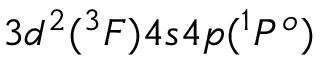Convert formula to latex. <formula><loc_0><loc_0><loc_500><loc_500>3 d ^ { 2 } ( ^ { 3 } F ) 4 s 4 p ( ^ { 1 } P ^ { o } )</formula> 